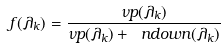<formula> <loc_0><loc_0><loc_500><loc_500>f ( \lambda _ { k } ) = \frac { \nu p ( \lambda _ { k } ) } { \nu p ( \lambda _ { k } ) + \ n d o w n ( \lambda _ { k } ) }</formula> 